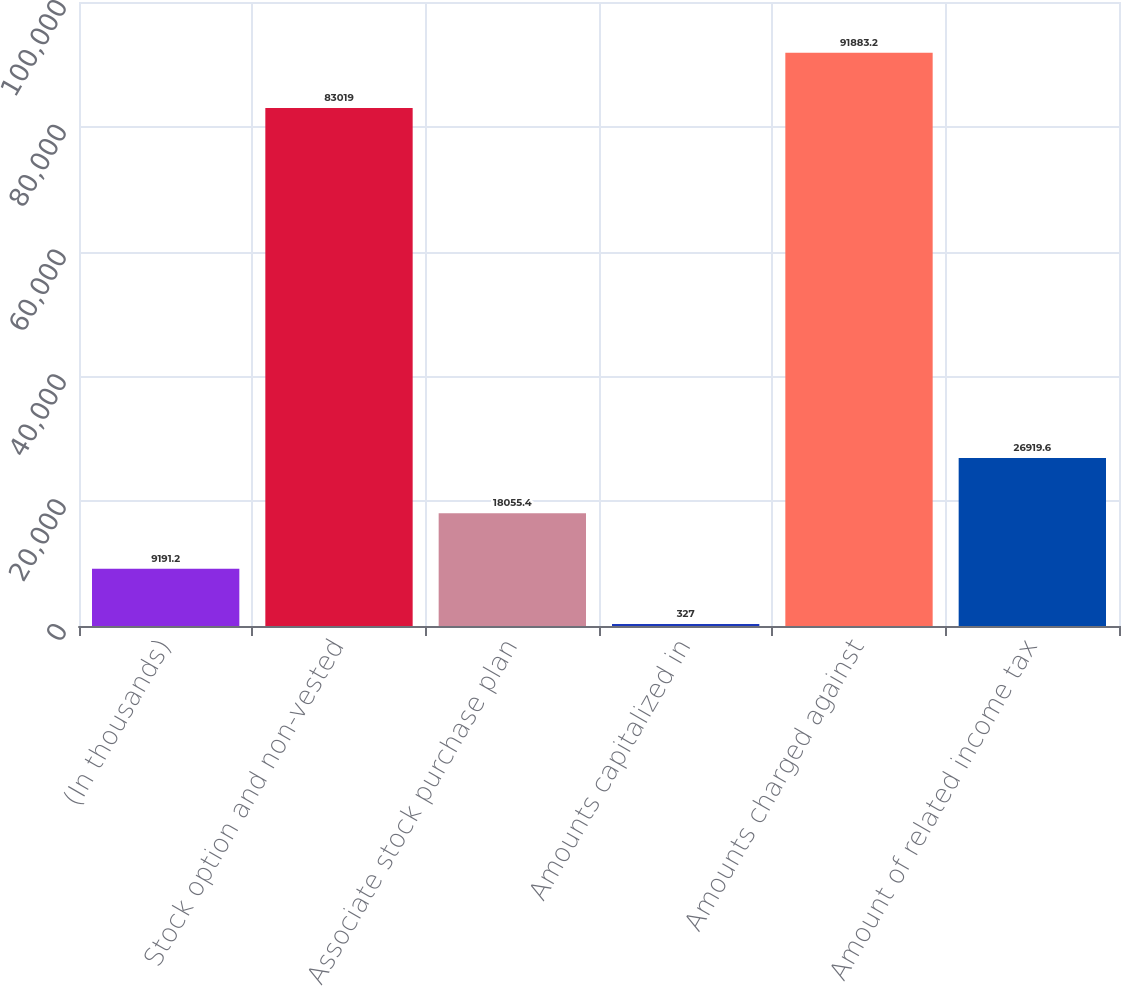Convert chart to OTSL. <chart><loc_0><loc_0><loc_500><loc_500><bar_chart><fcel>(In thousands)<fcel>Stock option and non-vested<fcel>Associate stock purchase plan<fcel>Amounts capitalized in<fcel>Amounts charged against<fcel>Amount of related income tax<nl><fcel>9191.2<fcel>83019<fcel>18055.4<fcel>327<fcel>91883.2<fcel>26919.6<nl></chart> 